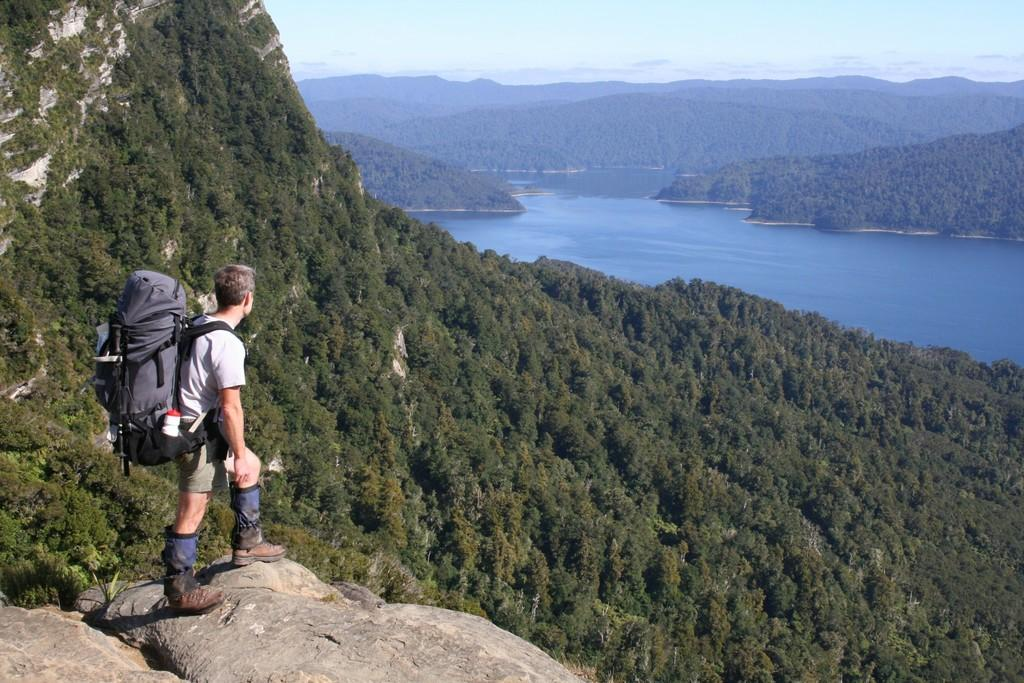Who is present in the image? There is a man in the image. What is the man carrying on his back? The man is standing with a bag on his back. What type of footwear is the man wearing? The man is wearing shoes. What type of natural environment is visible in the image? There are many trees and a river in the image. What type of quince is being used to make a statement in the image? There is no quince present in the image, nor is there any indication of a statement being made. 